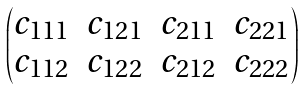<formula> <loc_0><loc_0><loc_500><loc_500>\begin{pmatrix} c _ { 1 1 1 } & c _ { 1 2 1 } & c _ { 2 1 1 } & c _ { 2 2 1 } \\ c _ { 1 1 2 } & c _ { 1 2 2 } & c _ { 2 1 2 } & c _ { 2 2 2 } \end{pmatrix}</formula> 